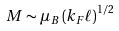<formula> <loc_0><loc_0><loc_500><loc_500>M \sim \mu _ { B } \left ( k _ { F } \ell \right ) ^ { 1 / 2 }</formula> 